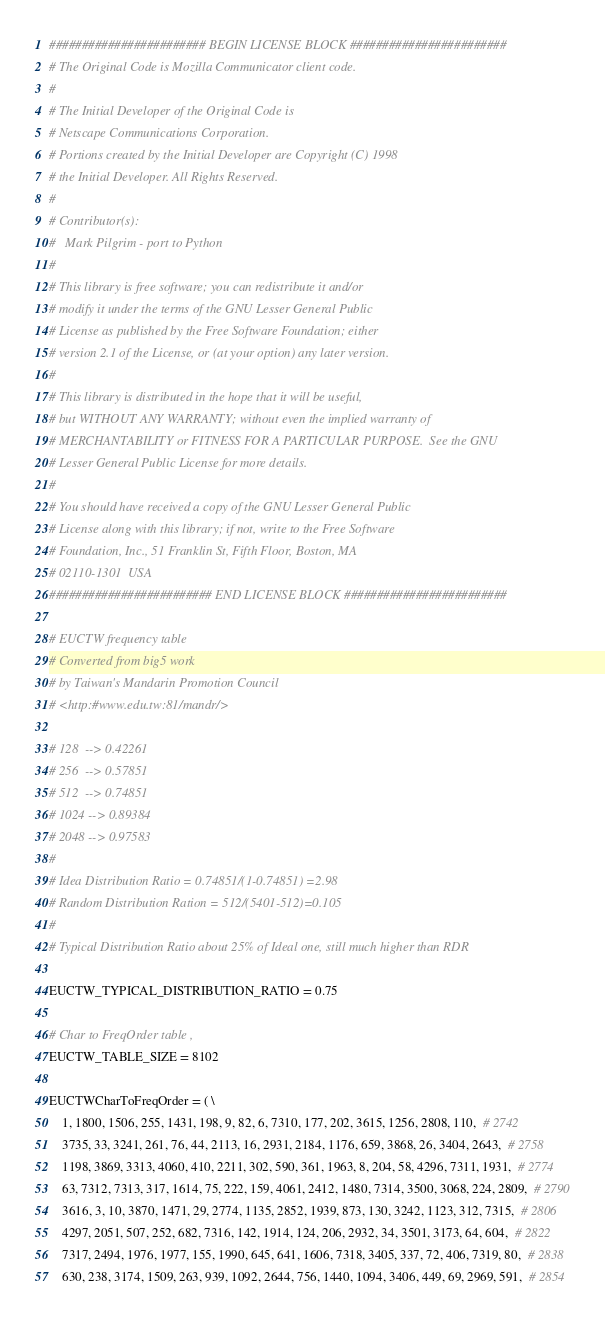<code> <loc_0><loc_0><loc_500><loc_500><_Python_>######################## BEGIN LICENSE BLOCK ########################
# The Original Code is Mozilla Communicator client code.
#
# The Initial Developer of the Original Code is
# Netscape Communications Corporation.
# Portions created by the Initial Developer are Copyright (C) 1998
# the Initial Developer. All Rights Reserved.
#
# Contributor(s):
#   Mark Pilgrim - port to Python
#
# This library is free software; you can redistribute it and/or
# modify it under the terms of the GNU Lesser General Public
# License as published by the Free Software Foundation; either
# version 2.1 of the License, or (at your option) any later version.
# 
# This library is distributed in the hope that it will be useful,
# but WITHOUT ANY WARRANTY; without even the implied warranty of
# MERCHANTABILITY or FITNESS FOR A PARTICULAR PURPOSE.  See the GNU
# Lesser General Public License for more details.
# 
# You should have received a copy of the GNU Lesser General Public
# License along with this library; if not, write to the Free Software
# Foundation, Inc., 51 Franklin St, Fifth Floor, Boston, MA
# 02110-1301  USA
######################### END LICENSE BLOCK #########################

# EUCTW frequency table
# Converted from big5 work 
# by Taiwan's Mandarin Promotion Council 
# <http:#www.edu.tw:81/mandr/>

# 128  --> 0.42261
# 256  --> 0.57851
# 512  --> 0.74851
# 1024 --> 0.89384
# 2048 --> 0.97583
#
# Idea Distribution Ratio = 0.74851/(1-0.74851) =2.98
# Random Distribution Ration = 512/(5401-512)=0.105
# 
# Typical Distribution Ratio about 25% of Ideal one, still much higher than RDR

EUCTW_TYPICAL_DISTRIBUTION_RATIO = 0.75

# Char to FreqOrder table , 
EUCTW_TABLE_SIZE = 8102

EUCTWCharToFreqOrder = ( \
    1, 1800, 1506, 255, 1431, 198, 9, 82, 6, 7310, 177, 202, 3615, 1256, 2808, 110,  # 2742
    3735, 33, 3241, 261, 76, 44, 2113, 16, 2931, 2184, 1176, 659, 3868, 26, 3404, 2643,  # 2758
    1198, 3869, 3313, 4060, 410, 2211, 302, 590, 361, 1963, 8, 204, 58, 4296, 7311, 1931,  # 2774
    63, 7312, 7313, 317, 1614, 75, 222, 159, 4061, 2412, 1480, 7314, 3500, 3068, 224, 2809,  # 2790
    3616, 3, 10, 3870, 1471, 29, 2774, 1135, 2852, 1939, 873, 130, 3242, 1123, 312, 7315,  # 2806
    4297, 2051, 507, 252, 682, 7316, 142, 1914, 124, 206, 2932, 34, 3501, 3173, 64, 604,  # 2822
    7317, 2494, 1976, 1977, 155, 1990, 645, 641, 1606, 7318, 3405, 337, 72, 406, 7319, 80,  # 2838
    630, 238, 3174, 1509, 263, 939, 1092, 2644, 756, 1440, 1094, 3406, 449, 69, 2969, 591,  # 2854</code> 